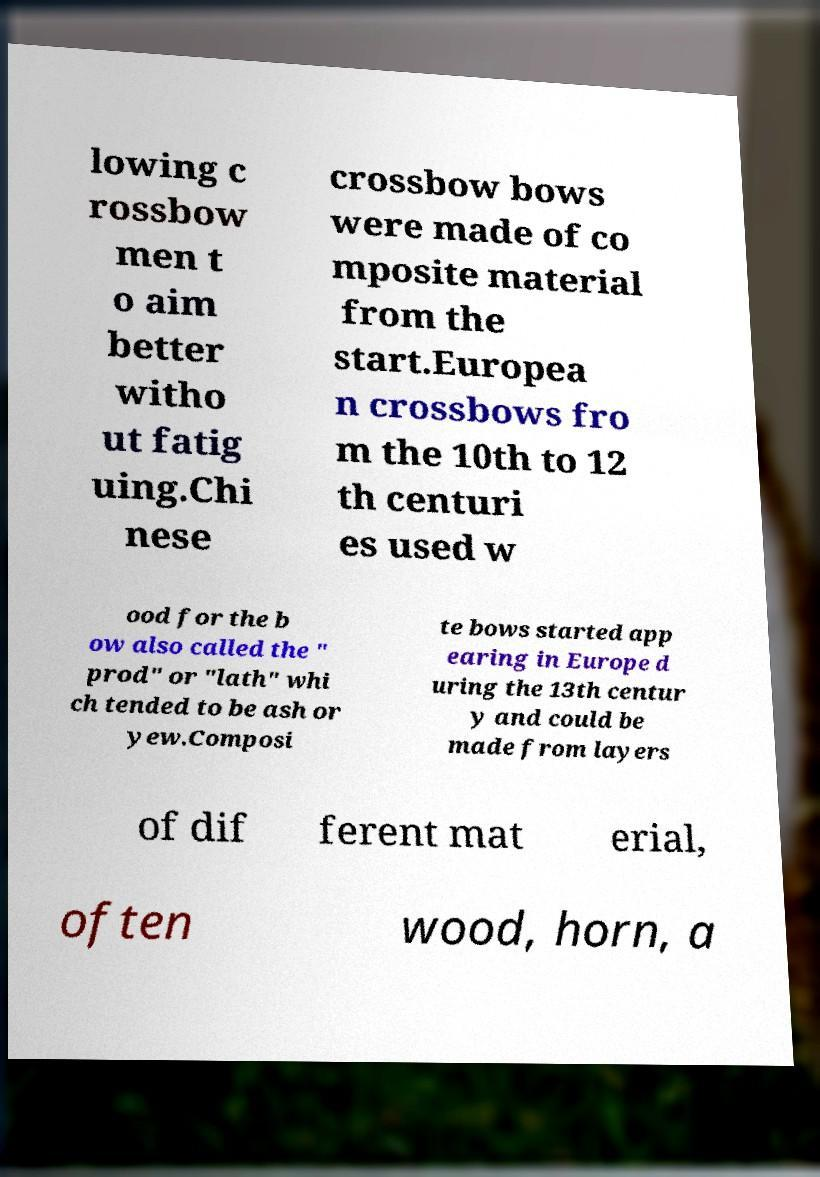Please read and relay the text visible in this image. What does it say? lowing c rossbow men t o aim better witho ut fatig uing.Chi nese crossbow bows were made of co mposite material from the start.Europea n crossbows fro m the 10th to 12 th centuri es used w ood for the b ow also called the " prod" or "lath" whi ch tended to be ash or yew.Composi te bows started app earing in Europe d uring the 13th centur y and could be made from layers of dif ferent mat erial, often wood, horn, a 